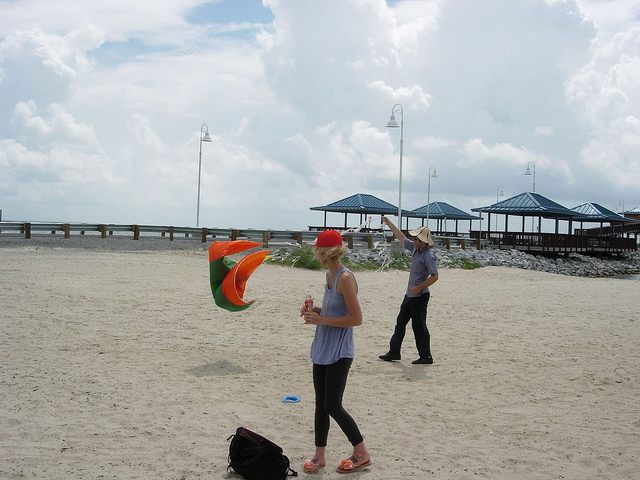<image>Does it look windy enough for this man to fly his kite successfully? It is unsure if it is windy enough for this man to fly his kite successfully. It could be either yes or no. Does it look windy enough for this man to fly his kite successfully? I am not sure if it looks windy enough for this man to fly his kite successfully. It can be both yes or no. 